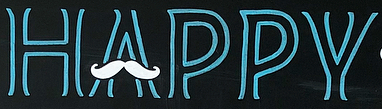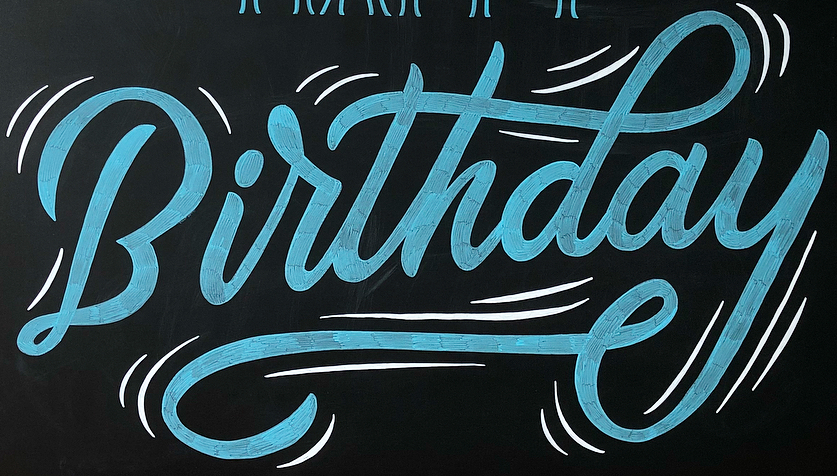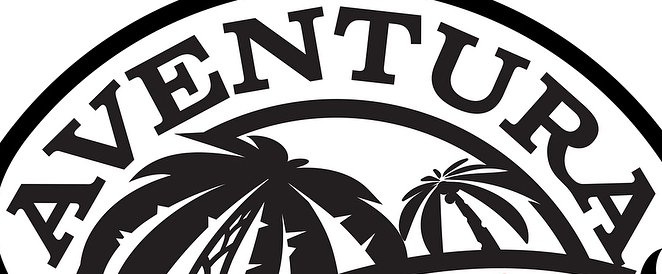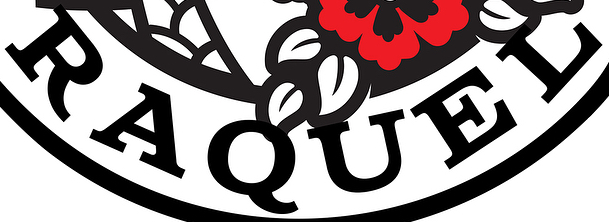Read the text from these images in sequence, separated by a semicolon. HAPPY; Birthday; AVENTURA; RAQUEL 